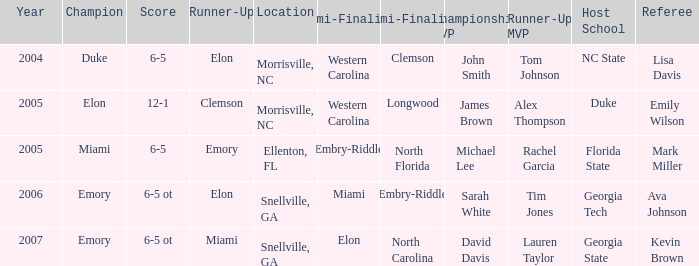Where was the final game played in 2007 Snellville, GA. Could you parse the entire table as a dict? {'header': ['Year', 'Champion', 'Score', 'Runner-Up', 'Location', 'Semi-Finalist #1', 'Semi-Finalist #2', 'Championship MVP', 'Runner-Up MVP', 'Host School', 'Referee'], 'rows': [['2004', 'Duke', '6-5', 'Elon', 'Morrisville, NC', 'Western Carolina', 'Clemson', 'John Smith', 'Tom Johnson', 'NC State', 'Lisa Davis'], ['2005', 'Elon', '12-1', 'Clemson', 'Morrisville, NC', 'Western Carolina', 'Longwood', 'James Brown', 'Alex Thompson', 'Duke', 'Emily Wilson'], ['2005', 'Miami', '6-5', 'Emory', 'Ellenton, FL', 'Embry-Riddle', 'North Florida', 'Michael Lee', 'Rachel Garcia', 'Florida State', 'Mark Miller'], ['2006', 'Emory', '6-5 ot', 'Elon', 'Snellville, GA', 'Miami', 'Embry-Riddle', 'Sarah White', 'Tim Jones', 'Georgia Tech', 'Ava Johnson'], ['2007', 'Emory', '6-5 ot', 'Miami', 'Snellville, GA', 'Elon', 'North Carolina', 'David Davis', 'Lauren Taylor', 'Georgia State', 'Kevin Brown']]} 